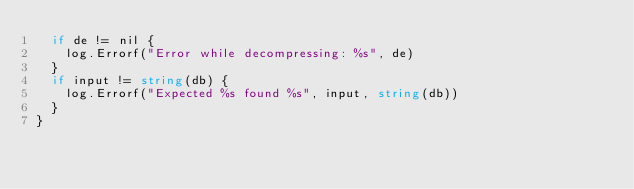<code> <loc_0><loc_0><loc_500><loc_500><_Go_>	if de != nil {
		log.Errorf("Error while decompressing: %s", de)
	}
	if input != string(db) {
		log.Errorf("Expected %s found %s", input, string(db))
	}
}
</code> 